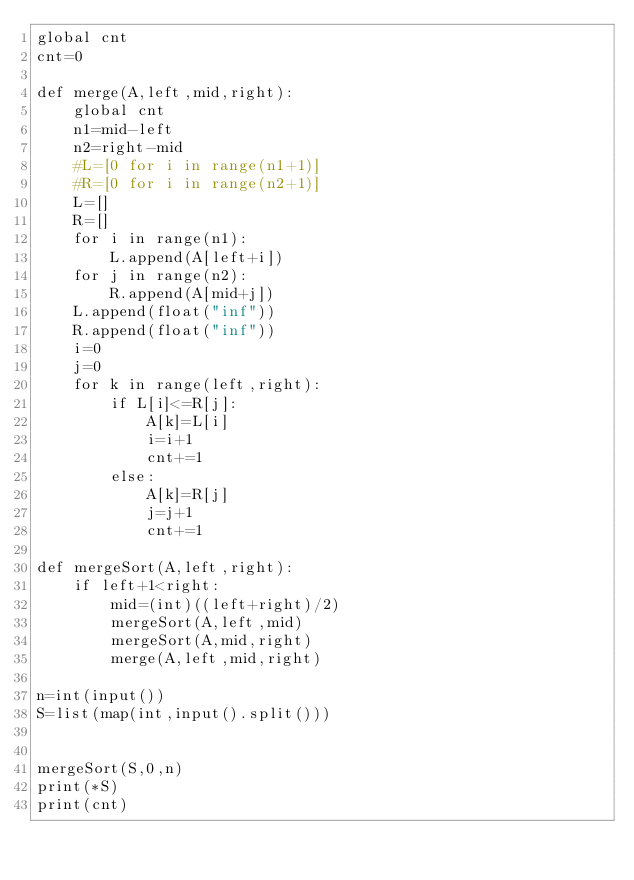<code> <loc_0><loc_0><loc_500><loc_500><_Python_>global cnt
cnt=0

def merge(A,left,mid,right):
    global cnt
    n1=mid-left
    n2=right-mid
    #L=[0 for i in range(n1+1)]
    #R=[0 for i in range(n2+1)]
    L=[]
    R=[]
    for i in range(n1):
        L.append(A[left+i])
    for j in range(n2):
        R.append(A[mid+j])
    L.append(float("inf"))
    R.append(float("inf"))
    i=0
    j=0
    for k in range(left,right):
        if L[i]<=R[j]:
            A[k]=L[i]
            i=i+1
            cnt+=1
        else:
            A[k]=R[j]
            j=j+1
            cnt+=1

def mergeSort(A,left,right):
    if left+1<right:
        mid=(int)((left+right)/2)
        mergeSort(A,left,mid)
        mergeSort(A,mid,right)
        merge(A,left,mid,right)

n=int(input())
S=list(map(int,input().split()))


mergeSort(S,0,n)
print(*S)
print(cnt)
</code> 